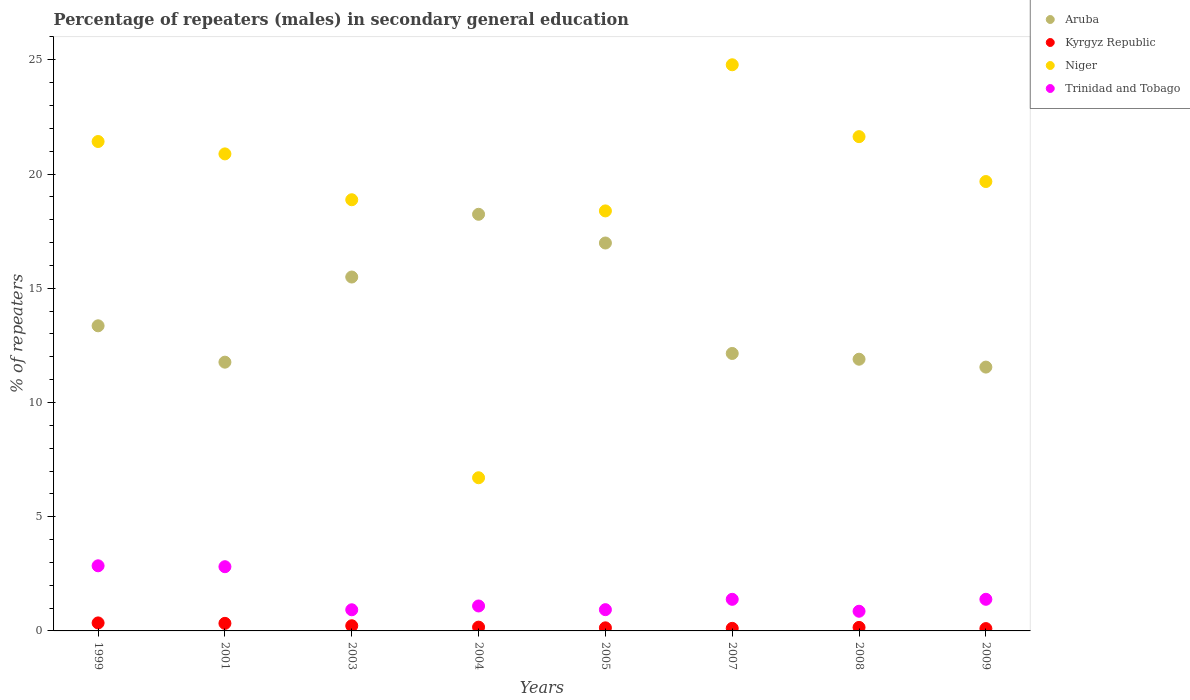Is the number of dotlines equal to the number of legend labels?
Provide a succinct answer. Yes. What is the percentage of male repeaters in Kyrgyz Republic in 1999?
Offer a terse response. 0.35. Across all years, what is the maximum percentage of male repeaters in Niger?
Keep it short and to the point. 24.78. Across all years, what is the minimum percentage of male repeaters in Kyrgyz Republic?
Your answer should be compact. 0.1. In which year was the percentage of male repeaters in Kyrgyz Republic minimum?
Offer a very short reply. 2009. What is the total percentage of male repeaters in Kyrgyz Republic in the graph?
Keep it short and to the point. 1.58. What is the difference between the percentage of male repeaters in Aruba in 2001 and that in 2009?
Offer a terse response. 0.22. What is the difference between the percentage of male repeaters in Trinidad and Tobago in 2005 and the percentage of male repeaters in Niger in 2008?
Keep it short and to the point. -20.71. What is the average percentage of male repeaters in Niger per year?
Make the answer very short. 19.05. In the year 2007, what is the difference between the percentage of male repeaters in Kyrgyz Republic and percentage of male repeaters in Aruba?
Keep it short and to the point. -12.03. In how many years, is the percentage of male repeaters in Aruba greater than 10 %?
Provide a succinct answer. 8. What is the ratio of the percentage of male repeaters in Kyrgyz Republic in 2005 to that in 2007?
Offer a very short reply. 1.2. Is the percentage of male repeaters in Trinidad and Tobago in 2008 less than that in 2009?
Your answer should be very brief. Yes. Is the difference between the percentage of male repeaters in Kyrgyz Republic in 2005 and 2009 greater than the difference between the percentage of male repeaters in Aruba in 2005 and 2009?
Your response must be concise. No. What is the difference between the highest and the second highest percentage of male repeaters in Trinidad and Tobago?
Make the answer very short. 0.04. What is the difference between the highest and the lowest percentage of male repeaters in Niger?
Ensure brevity in your answer.  18.08. In how many years, is the percentage of male repeaters in Niger greater than the average percentage of male repeaters in Niger taken over all years?
Make the answer very short. 5. Does the percentage of male repeaters in Trinidad and Tobago monotonically increase over the years?
Provide a succinct answer. No. Is the percentage of male repeaters in Trinidad and Tobago strictly greater than the percentage of male repeaters in Niger over the years?
Your answer should be very brief. No. Is the percentage of male repeaters in Aruba strictly less than the percentage of male repeaters in Niger over the years?
Give a very brief answer. No. How many dotlines are there?
Make the answer very short. 4. What is the difference between two consecutive major ticks on the Y-axis?
Offer a very short reply. 5. Are the values on the major ticks of Y-axis written in scientific E-notation?
Provide a succinct answer. No. Does the graph contain any zero values?
Ensure brevity in your answer.  No. Does the graph contain grids?
Your answer should be very brief. No. How are the legend labels stacked?
Your response must be concise. Vertical. What is the title of the graph?
Give a very brief answer. Percentage of repeaters (males) in secondary general education. Does "Nepal" appear as one of the legend labels in the graph?
Offer a very short reply. No. What is the label or title of the X-axis?
Offer a very short reply. Years. What is the label or title of the Y-axis?
Make the answer very short. % of repeaters. What is the % of repeaters in Aruba in 1999?
Keep it short and to the point. 13.36. What is the % of repeaters in Kyrgyz Republic in 1999?
Provide a short and direct response. 0.35. What is the % of repeaters in Niger in 1999?
Provide a succinct answer. 21.42. What is the % of repeaters of Trinidad and Tobago in 1999?
Offer a very short reply. 2.85. What is the % of repeaters in Aruba in 2001?
Offer a terse response. 11.76. What is the % of repeaters in Kyrgyz Republic in 2001?
Offer a terse response. 0.33. What is the % of repeaters in Niger in 2001?
Offer a very short reply. 20.88. What is the % of repeaters of Trinidad and Tobago in 2001?
Your response must be concise. 2.81. What is the % of repeaters of Aruba in 2003?
Your answer should be compact. 15.49. What is the % of repeaters of Kyrgyz Republic in 2003?
Your answer should be compact. 0.23. What is the % of repeaters of Niger in 2003?
Make the answer very short. 18.87. What is the % of repeaters of Trinidad and Tobago in 2003?
Offer a terse response. 0.93. What is the % of repeaters in Aruba in 2004?
Your response must be concise. 18.24. What is the % of repeaters of Kyrgyz Republic in 2004?
Your answer should be very brief. 0.17. What is the % of repeaters in Niger in 2004?
Provide a succinct answer. 6.71. What is the % of repeaters in Trinidad and Tobago in 2004?
Give a very brief answer. 1.09. What is the % of repeaters of Aruba in 2005?
Offer a very short reply. 16.98. What is the % of repeaters in Kyrgyz Republic in 2005?
Give a very brief answer. 0.14. What is the % of repeaters in Niger in 2005?
Keep it short and to the point. 18.39. What is the % of repeaters of Trinidad and Tobago in 2005?
Ensure brevity in your answer.  0.93. What is the % of repeaters of Aruba in 2007?
Provide a succinct answer. 12.15. What is the % of repeaters in Kyrgyz Republic in 2007?
Provide a short and direct response. 0.11. What is the % of repeaters in Niger in 2007?
Provide a succinct answer. 24.78. What is the % of repeaters in Trinidad and Tobago in 2007?
Ensure brevity in your answer.  1.38. What is the % of repeaters in Aruba in 2008?
Your answer should be compact. 11.89. What is the % of repeaters in Kyrgyz Republic in 2008?
Make the answer very short. 0.15. What is the % of repeaters in Niger in 2008?
Your response must be concise. 21.64. What is the % of repeaters in Trinidad and Tobago in 2008?
Your answer should be compact. 0.86. What is the % of repeaters in Aruba in 2009?
Your response must be concise. 11.55. What is the % of repeaters of Kyrgyz Republic in 2009?
Provide a short and direct response. 0.1. What is the % of repeaters in Niger in 2009?
Keep it short and to the point. 19.67. What is the % of repeaters in Trinidad and Tobago in 2009?
Your answer should be compact. 1.38. Across all years, what is the maximum % of repeaters of Aruba?
Provide a succinct answer. 18.24. Across all years, what is the maximum % of repeaters in Kyrgyz Republic?
Ensure brevity in your answer.  0.35. Across all years, what is the maximum % of repeaters in Niger?
Give a very brief answer. 24.78. Across all years, what is the maximum % of repeaters of Trinidad and Tobago?
Your answer should be compact. 2.85. Across all years, what is the minimum % of repeaters of Aruba?
Your response must be concise. 11.55. Across all years, what is the minimum % of repeaters of Kyrgyz Republic?
Give a very brief answer. 0.1. Across all years, what is the minimum % of repeaters of Niger?
Your answer should be very brief. 6.71. Across all years, what is the minimum % of repeaters of Trinidad and Tobago?
Make the answer very short. 0.86. What is the total % of repeaters in Aruba in the graph?
Your response must be concise. 111.42. What is the total % of repeaters in Kyrgyz Republic in the graph?
Offer a very short reply. 1.58. What is the total % of repeaters of Niger in the graph?
Give a very brief answer. 152.36. What is the total % of repeaters of Trinidad and Tobago in the graph?
Your response must be concise. 12.24. What is the difference between the % of repeaters in Aruba in 1999 and that in 2001?
Give a very brief answer. 1.59. What is the difference between the % of repeaters in Kyrgyz Republic in 1999 and that in 2001?
Offer a terse response. 0.02. What is the difference between the % of repeaters of Niger in 1999 and that in 2001?
Provide a short and direct response. 0.54. What is the difference between the % of repeaters in Trinidad and Tobago in 1999 and that in 2001?
Offer a terse response. 0.04. What is the difference between the % of repeaters of Aruba in 1999 and that in 2003?
Give a very brief answer. -2.14. What is the difference between the % of repeaters in Kyrgyz Republic in 1999 and that in 2003?
Your response must be concise. 0.12. What is the difference between the % of repeaters in Niger in 1999 and that in 2003?
Offer a terse response. 2.55. What is the difference between the % of repeaters in Trinidad and Tobago in 1999 and that in 2003?
Keep it short and to the point. 1.92. What is the difference between the % of repeaters in Aruba in 1999 and that in 2004?
Ensure brevity in your answer.  -4.88. What is the difference between the % of repeaters in Kyrgyz Republic in 1999 and that in 2004?
Offer a very short reply. 0.18. What is the difference between the % of repeaters of Niger in 1999 and that in 2004?
Give a very brief answer. 14.72. What is the difference between the % of repeaters of Trinidad and Tobago in 1999 and that in 2004?
Make the answer very short. 1.76. What is the difference between the % of repeaters of Aruba in 1999 and that in 2005?
Provide a succinct answer. -3.62. What is the difference between the % of repeaters in Kyrgyz Republic in 1999 and that in 2005?
Offer a terse response. 0.22. What is the difference between the % of repeaters of Niger in 1999 and that in 2005?
Your answer should be very brief. 3.04. What is the difference between the % of repeaters of Trinidad and Tobago in 1999 and that in 2005?
Ensure brevity in your answer.  1.92. What is the difference between the % of repeaters in Aruba in 1999 and that in 2007?
Keep it short and to the point. 1.21. What is the difference between the % of repeaters in Kyrgyz Republic in 1999 and that in 2007?
Your answer should be very brief. 0.24. What is the difference between the % of repeaters in Niger in 1999 and that in 2007?
Ensure brevity in your answer.  -3.36. What is the difference between the % of repeaters in Trinidad and Tobago in 1999 and that in 2007?
Provide a succinct answer. 1.47. What is the difference between the % of repeaters in Aruba in 1999 and that in 2008?
Provide a short and direct response. 1.46. What is the difference between the % of repeaters of Kyrgyz Republic in 1999 and that in 2008?
Make the answer very short. 0.2. What is the difference between the % of repeaters in Niger in 1999 and that in 2008?
Provide a short and direct response. -0.21. What is the difference between the % of repeaters of Trinidad and Tobago in 1999 and that in 2008?
Your answer should be very brief. 1.99. What is the difference between the % of repeaters of Aruba in 1999 and that in 2009?
Ensure brevity in your answer.  1.81. What is the difference between the % of repeaters in Kyrgyz Republic in 1999 and that in 2009?
Make the answer very short. 0.25. What is the difference between the % of repeaters of Niger in 1999 and that in 2009?
Ensure brevity in your answer.  1.75. What is the difference between the % of repeaters of Trinidad and Tobago in 1999 and that in 2009?
Keep it short and to the point. 1.47. What is the difference between the % of repeaters in Aruba in 2001 and that in 2003?
Give a very brief answer. -3.73. What is the difference between the % of repeaters of Kyrgyz Republic in 2001 and that in 2003?
Give a very brief answer. 0.1. What is the difference between the % of repeaters in Niger in 2001 and that in 2003?
Give a very brief answer. 2.01. What is the difference between the % of repeaters in Trinidad and Tobago in 2001 and that in 2003?
Your answer should be compact. 1.89. What is the difference between the % of repeaters in Aruba in 2001 and that in 2004?
Provide a succinct answer. -6.47. What is the difference between the % of repeaters in Kyrgyz Republic in 2001 and that in 2004?
Provide a succinct answer. 0.17. What is the difference between the % of repeaters of Niger in 2001 and that in 2004?
Your answer should be very brief. 14.18. What is the difference between the % of repeaters in Trinidad and Tobago in 2001 and that in 2004?
Make the answer very short. 1.72. What is the difference between the % of repeaters of Aruba in 2001 and that in 2005?
Provide a short and direct response. -5.22. What is the difference between the % of repeaters in Kyrgyz Republic in 2001 and that in 2005?
Provide a succinct answer. 0.2. What is the difference between the % of repeaters of Niger in 2001 and that in 2005?
Provide a short and direct response. 2.5. What is the difference between the % of repeaters in Trinidad and Tobago in 2001 and that in 2005?
Make the answer very short. 1.88. What is the difference between the % of repeaters of Aruba in 2001 and that in 2007?
Offer a very short reply. -0.38. What is the difference between the % of repeaters of Kyrgyz Republic in 2001 and that in 2007?
Provide a short and direct response. 0.22. What is the difference between the % of repeaters in Niger in 2001 and that in 2007?
Offer a terse response. -3.9. What is the difference between the % of repeaters in Trinidad and Tobago in 2001 and that in 2007?
Keep it short and to the point. 1.43. What is the difference between the % of repeaters of Aruba in 2001 and that in 2008?
Provide a succinct answer. -0.13. What is the difference between the % of repeaters of Kyrgyz Republic in 2001 and that in 2008?
Provide a short and direct response. 0.18. What is the difference between the % of repeaters of Niger in 2001 and that in 2008?
Your answer should be compact. -0.75. What is the difference between the % of repeaters of Trinidad and Tobago in 2001 and that in 2008?
Your answer should be very brief. 1.95. What is the difference between the % of repeaters in Aruba in 2001 and that in 2009?
Offer a very short reply. 0.22. What is the difference between the % of repeaters in Kyrgyz Republic in 2001 and that in 2009?
Your answer should be very brief. 0.23. What is the difference between the % of repeaters in Niger in 2001 and that in 2009?
Offer a very short reply. 1.21. What is the difference between the % of repeaters of Trinidad and Tobago in 2001 and that in 2009?
Keep it short and to the point. 1.43. What is the difference between the % of repeaters of Aruba in 2003 and that in 2004?
Offer a terse response. -2.75. What is the difference between the % of repeaters of Kyrgyz Republic in 2003 and that in 2004?
Offer a very short reply. 0.06. What is the difference between the % of repeaters in Niger in 2003 and that in 2004?
Make the answer very short. 12.17. What is the difference between the % of repeaters in Trinidad and Tobago in 2003 and that in 2004?
Provide a succinct answer. -0.17. What is the difference between the % of repeaters in Aruba in 2003 and that in 2005?
Offer a terse response. -1.49. What is the difference between the % of repeaters in Kyrgyz Republic in 2003 and that in 2005?
Your answer should be very brief. 0.09. What is the difference between the % of repeaters in Niger in 2003 and that in 2005?
Your response must be concise. 0.49. What is the difference between the % of repeaters in Trinidad and Tobago in 2003 and that in 2005?
Make the answer very short. -0. What is the difference between the % of repeaters of Aruba in 2003 and that in 2007?
Provide a short and direct response. 3.35. What is the difference between the % of repeaters in Kyrgyz Republic in 2003 and that in 2007?
Make the answer very short. 0.11. What is the difference between the % of repeaters of Niger in 2003 and that in 2007?
Offer a very short reply. -5.91. What is the difference between the % of repeaters of Trinidad and Tobago in 2003 and that in 2007?
Provide a short and direct response. -0.46. What is the difference between the % of repeaters in Aruba in 2003 and that in 2008?
Offer a very short reply. 3.6. What is the difference between the % of repeaters of Kyrgyz Republic in 2003 and that in 2008?
Your answer should be very brief. 0.07. What is the difference between the % of repeaters of Niger in 2003 and that in 2008?
Give a very brief answer. -2.76. What is the difference between the % of repeaters in Trinidad and Tobago in 2003 and that in 2008?
Provide a short and direct response. 0.06. What is the difference between the % of repeaters of Aruba in 2003 and that in 2009?
Provide a short and direct response. 3.94. What is the difference between the % of repeaters in Kyrgyz Republic in 2003 and that in 2009?
Provide a short and direct response. 0.12. What is the difference between the % of repeaters of Niger in 2003 and that in 2009?
Your response must be concise. -0.8. What is the difference between the % of repeaters of Trinidad and Tobago in 2003 and that in 2009?
Your answer should be very brief. -0.46. What is the difference between the % of repeaters of Aruba in 2004 and that in 2005?
Your answer should be very brief. 1.26. What is the difference between the % of repeaters of Kyrgyz Republic in 2004 and that in 2005?
Your answer should be compact. 0.03. What is the difference between the % of repeaters in Niger in 2004 and that in 2005?
Your response must be concise. -11.68. What is the difference between the % of repeaters of Trinidad and Tobago in 2004 and that in 2005?
Give a very brief answer. 0.16. What is the difference between the % of repeaters in Aruba in 2004 and that in 2007?
Give a very brief answer. 6.09. What is the difference between the % of repeaters in Kyrgyz Republic in 2004 and that in 2007?
Provide a succinct answer. 0.05. What is the difference between the % of repeaters of Niger in 2004 and that in 2007?
Keep it short and to the point. -18.08. What is the difference between the % of repeaters of Trinidad and Tobago in 2004 and that in 2007?
Provide a succinct answer. -0.29. What is the difference between the % of repeaters in Aruba in 2004 and that in 2008?
Give a very brief answer. 6.34. What is the difference between the % of repeaters in Kyrgyz Republic in 2004 and that in 2008?
Your response must be concise. 0.01. What is the difference between the % of repeaters in Niger in 2004 and that in 2008?
Offer a very short reply. -14.93. What is the difference between the % of repeaters in Trinidad and Tobago in 2004 and that in 2008?
Your response must be concise. 0.23. What is the difference between the % of repeaters in Aruba in 2004 and that in 2009?
Provide a short and direct response. 6.69. What is the difference between the % of repeaters of Kyrgyz Republic in 2004 and that in 2009?
Your answer should be very brief. 0.06. What is the difference between the % of repeaters of Niger in 2004 and that in 2009?
Your answer should be compact. -12.97. What is the difference between the % of repeaters of Trinidad and Tobago in 2004 and that in 2009?
Ensure brevity in your answer.  -0.29. What is the difference between the % of repeaters of Aruba in 2005 and that in 2007?
Your answer should be very brief. 4.84. What is the difference between the % of repeaters of Kyrgyz Republic in 2005 and that in 2007?
Your answer should be compact. 0.02. What is the difference between the % of repeaters in Niger in 2005 and that in 2007?
Give a very brief answer. -6.4. What is the difference between the % of repeaters of Trinidad and Tobago in 2005 and that in 2007?
Offer a very short reply. -0.45. What is the difference between the % of repeaters of Aruba in 2005 and that in 2008?
Your response must be concise. 5.09. What is the difference between the % of repeaters in Kyrgyz Republic in 2005 and that in 2008?
Ensure brevity in your answer.  -0.02. What is the difference between the % of repeaters of Niger in 2005 and that in 2008?
Your answer should be compact. -3.25. What is the difference between the % of repeaters in Trinidad and Tobago in 2005 and that in 2008?
Give a very brief answer. 0.07. What is the difference between the % of repeaters of Aruba in 2005 and that in 2009?
Give a very brief answer. 5.43. What is the difference between the % of repeaters of Kyrgyz Republic in 2005 and that in 2009?
Provide a succinct answer. 0.03. What is the difference between the % of repeaters in Niger in 2005 and that in 2009?
Give a very brief answer. -1.29. What is the difference between the % of repeaters in Trinidad and Tobago in 2005 and that in 2009?
Offer a very short reply. -0.45. What is the difference between the % of repeaters of Aruba in 2007 and that in 2008?
Give a very brief answer. 0.25. What is the difference between the % of repeaters of Kyrgyz Republic in 2007 and that in 2008?
Your response must be concise. -0.04. What is the difference between the % of repeaters of Niger in 2007 and that in 2008?
Make the answer very short. 3.15. What is the difference between the % of repeaters in Trinidad and Tobago in 2007 and that in 2008?
Give a very brief answer. 0.52. What is the difference between the % of repeaters in Aruba in 2007 and that in 2009?
Keep it short and to the point. 0.6. What is the difference between the % of repeaters of Kyrgyz Republic in 2007 and that in 2009?
Make the answer very short. 0.01. What is the difference between the % of repeaters in Niger in 2007 and that in 2009?
Your answer should be compact. 5.11. What is the difference between the % of repeaters in Trinidad and Tobago in 2007 and that in 2009?
Your answer should be compact. -0. What is the difference between the % of repeaters in Aruba in 2008 and that in 2009?
Make the answer very short. 0.34. What is the difference between the % of repeaters in Kyrgyz Republic in 2008 and that in 2009?
Ensure brevity in your answer.  0.05. What is the difference between the % of repeaters of Niger in 2008 and that in 2009?
Give a very brief answer. 1.96. What is the difference between the % of repeaters of Trinidad and Tobago in 2008 and that in 2009?
Your answer should be compact. -0.52. What is the difference between the % of repeaters in Aruba in 1999 and the % of repeaters in Kyrgyz Republic in 2001?
Provide a short and direct response. 13.03. What is the difference between the % of repeaters of Aruba in 1999 and the % of repeaters of Niger in 2001?
Offer a very short reply. -7.53. What is the difference between the % of repeaters in Aruba in 1999 and the % of repeaters in Trinidad and Tobago in 2001?
Offer a very short reply. 10.55. What is the difference between the % of repeaters of Kyrgyz Republic in 1999 and the % of repeaters of Niger in 2001?
Provide a short and direct response. -20.53. What is the difference between the % of repeaters in Kyrgyz Republic in 1999 and the % of repeaters in Trinidad and Tobago in 2001?
Offer a very short reply. -2.46. What is the difference between the % of repeaters of Niger in 1999 and the % of repeaters of Trinidad and Tobago in 2001?
Provide a short and direct response. 18.61. What is the difference between the % of repeaters of Aruba in 1999 and the % of repeaters of Kyrgyz Republic in 2003?
Give a very brief answer. 13.13. What is the difference between the % of repeaters of Aruba in 1999 and the % of repeaters of Niger in 2003?
Your answer should be compact. -5.52. What is the difference between the % of repeaters of Aruba in 1999 and the % of repeaters of Trinidad and Tobago in 2003?
Your answer should be compact. 12.43. What is the difference between the % of repeaters of Kyrgyz Republic in 1999 and the % of repeaters of Niger in 2003?
Offer a very short reply. -18.52. What is the difference between the % of repeaters of Kyrgyz Republic in 1999 and the % of repeaters of Trinidad and Tobago in 2003?
Offer a very short reply. -0.58. What is the difference between the % of repeaters in Niger in 1999 and the % of repeaters in Trinidad and Tobago in 2003?
Provide a short and direct response. 20.5. What is the difference between the % of repeaters of Aruba in 1999 and the % of repeaters of Kyrgyz Republic in 2004?
Ensure brevity in your answer.  13.19. What is the difference between the % of repeaters of Aruba in 1999 and the % of repeaters of Niger in 2004?
Give a very brief answer. 6.65. What is the difference between the % of repeaters of Aruba in 1999 and the % of repeaters of Trinidad and Tobago in 2004?
Give a very brief answer. 12.26. What is the difference between the % of repeaters of Kyrgyz Republic in 1999 and the % of repeaters of Niger in 2004?
Provide a short and direct response. -6.35. What is the difference between the % of repeaters of Kyrgyz Republic in 1999 and the % of repeaters of Trinidad and Tobago in 2004?
Offer a very short reply. -0.74. What is the difference between the % of repeaters of Niger in 1999 and the % of repeaters of Trinidad and Tobago in 2004?
Your response must be concise. 20.33. What is the difference between the % of repeaters of Aruba in 1999 and the % of repeaters of Kyrgyz Republic in 2005?
Provide a succinct answer. 13.22. What is the difference between the % of repeaters in Aruba in 1999 and the % of repeaters in Niger in 2005?
Keep it short and to the point. -5.03. What is the difference between the % of repeaters in Aruba in 1999 and the % of repeaters in Trinidad and Tobago in 2005?
Give a very brief answer. 12.43. What is the difference between the % of repeaters in Kyrgyz Republic in 1999 and the % of repeaters in Niger in 2005?
Your response must be concise. -18.04. What is the difference between the % of repeaters of Kyrgyz Republic in 1999 and the % of repeaters of Trinidad and Tobago in 2005?
Your answer should be compact. -0.58. What is the difference between the % of repeaters in Niger in 1999 and the % of repeaters in Trinidad and Tobago in 2005?
Keep it short and to the point. 20.49. What is the difference between the % of repeaters in Aruba in 1999 and the % of repeaters in Kyrgyz Republic in 2007?
Provide a succinct answer. 13.24. What is the difference between the % of repeaters in Aruba in 1999 and the % of repeaters in Niger in 2007?
Keep it short and to the point. -11.43. What is the difference between the % of repeaters of Aruba in 1999 and the % of repeaters of Trinidad and Tobago in 2007?
Keep it short and to the point. 11.97. What is the difference between the % of repeaters in Kyrgyz Republic in 1999 and the % of repeaters in Niger in 2007?
Your answer should be compact. -24.43. What is the difference between the % of repeaters in Kyrgyz Republic in 1999 and the % of repeaters in Trinidad and Tobago in 2007?
Provide a succinct answer. -1.03. What is the difference between the % of repeaters in Niger in 1999 and the % of repeaters in Trinidad and Tobago in 2007?
Keep it short and to the point. 20.04. What is the difference between the % of repeaters in Aruba in 1999 and the % of repeaters in Kyrgyz Republic in 2008?
Your answer should be very brief. 13.2. What is the difference between the % of repeaters in Aruba in 1999 and the % of repeaters in Niger in 2008?
Give a very brief answer. -8.28. What is the difference between the % of repeaters in Aruba in 1999 and the % of repeaters in Trinidad and Tobago in 2008?
Give a very brief answer. 12.5. What is the difference between the % of repeaters of Kyrgyz Republic in 1999 and the % of repeaters of Niger in 2008?
Your answer should be very brief. -21.29. What is the difference between the % of repeaters of Kyrgyz Republic in 1999 and the % of repeaters of Trinidad and Tobago in 2008?
Your answer should be very brief. -0.51. What is the difference between the % of repeaters in Niger in 1999 and the % of repeaters in Trinidad and Tobago in 2008?
Provide a short and direct response. 20.56. What is the difference between the % of repeaters of Aruba in 1999 and the % of repeaters of Kyrgyz Republic in 2009?
Ensure brevity in your answer.  13.25. What is the difference between the % of repeaters in Aruba in 1999 and the % of repeaters in Niger in 2009?
Ensure brevity in your answer.  -6.32. What is the difference between the % of repeaters of Aruba in 1999 and the % of repeaters of Trinidad and Tobago in 2009?
Give a very brief answer. 11.97. What is the difference between the % of repeaters in Kyrgyz Republic in 1999 and the % of repeaters in Niger in 2009?
Ensure brevity in your answer.  -19.32. What is the difference between the % of repeaters of Kyrgyz Republic in 1999 and the % of repeaters of Trinidad and Tobago in 2009?
Make the answer very short. -1.03. What is the difference between the % of repeaters of Niger in 1999 and the % of repeaters of Trinidad and Tobago in 2009?
Your response must be concise. 20.04. What is the difference between the % of repeaters in Aruba in 2001 and the % of repeaters in Kyrgyz Republic in 2003?
Offer a terse response. 11.54. What is the difference between the % of repeaters of Aruba in 2001 and the % of repeaters of Niger in 2003?
Keep it short and to the point. -7.11. What is the difference between the % of repeaters in Aruba in 2001 and the % of repeaters in Trinidad and Tobago in 2003?
Your answer should be very brief. 10.84. What is the difference between the % of repeaters in Kyrgyz Republic in 2001 and the % of repeaters in Niger in 2003?
Give a very brief answer. -18.54. What is the difference between the % of repeaters of Kyrgyz Republic in 2001 and the % of repeaters of Trinidad and Tobago in 2003?
Offer a terse response. -0.59. What is the difference between the % of repeaters of Niger in 2001 and the % of repeaters of Trinidad and Tobago in 2003?
Keep it short and to the point. 19.96. What is the difference between the % of repeaters of Aruba in 2001 and the % of repeaters of Kyrgyz Republic in 2004?
Make the answer very short. 11.6. What is the difference between the % of repeaters in Aruba in 2001 and the % of repeaters in Niger in 2004?
Provide a succinct answer. 5.06. What is the difference between the % of repeaters in Aruba in 2001 and the % of repeaters in Trinidad and Tobago in 2004?
Offer a very short reply. 10.67. What is the difference between the % of repeaters of Kyrgyz Republic in 2001 and the % of repeaters of Niger in 2004?
Your answer should be compact. -6.37. What is the difference between the % of repeaters in Kyrgyz Republic in 2001 and the % of repeaters in Trinidad and Tobago in 2004?
Keep it short and to the point. -0.76. What is the difference between the % of repeaters of Niger in 2001 and the % of repeaters of Trinidad and Tobago in 2004?
Ensure brevity in your answer.  19.79. What is the difference between the % of repeaters in Aruba in 2001 and the % of repeaters in Kyrgyz Republic in 2005?
Provide a succinct answer. 11.63. What is the difference between the % of repeaters of Aruba in 2001 and the % of repeaters of Niger in 2005?
Offer a terse response. -6.62. What is the difference between the % of repeaters in Aruba in 2001 and the % of repeaters in Trinidad and Tobago in 2005?
Ensure brevity in your answer.  10.83. What is the difference between the % of repeaters of Kyrgyz Republic in 2001 and the % of repeaters of Niger in 2005?
Ensure brevity in your answer.  -18.05. What is the difference between the % of repeaters in Kyrgyz Republic in 2001 and the % of repeaters in Trinidad and Tobago in 2005?
Keep it short and to the point. -0.6. What is the difference between the % of repeaters in Niger in 2001 and the % of repeaters in Trinidad and Tobago in 2005?
Your answer should be very brief. 19.95. What is the difference between the % of repeaters in Aruba in 2001 and the % of repeaters in Kyrgyz Republic in 2007?
Ensure brevity in your answer.  11.65. What is the difference between the % of repeaters in Aruba in 2001 and the % of repeaters in Niger in 2007?
Your answer should be compact. -13.02. What is the difference between the % of repeaters of Aruba in 2001 and the % of repeaters of Trinidad and Tobago in 2007?
Your answer should be very brief. 10.38. What is the difference between the % of repeaters of Kyrgyz Republic in 2001 and the % of repeaters of Niger in 2007?
Offer a terse response. -24.45. What is the difference between the % of repeaters in Kyrgyz Republic in 2001 and the % of repeaters in Trinidad and Tobago in 2007?
Offer a terse response. -1.05. What is the difference between the % of repeaters in Niger in 2001 and the % of repeaters in Trinidad and Tobago in 2007?
Give a very brief answer. 19.5. What is the difference between the % of repeaters of Aruba in 2001 and the % of repeaters of Kyrgyz Republic in 2008?
Ensure brevity in your answer.  11.61. What is the difference between the % of repeaters of Aruba in 2001 and the % of repeaters of Niger in 2008?
Your answer should be compact. -9.87. What is the difference between the % of repeaters of Aruba in 2001 and the % of repeaters of Trinidad and Tobago in 2008?
Your answer should be very brief. 10.9. What is the difference between the % of repeaters of Kyrgyz Republic in 2001 and the % of repeaters of Niger in 2008?
Give a very brief answer. -21.31. What is the difference between the % of repeaters in Kyrgyz Republic in 2001 and the % of repeaters in Trinidad and Tobago in 2008?
Give a very brief answer. -0.53. What is the difference between the % of repeaters of Niger in 2001 and the % of repeaters of Trinidad and Tobago in 2008?
Provide a succinct answer. 20.02. What is the difference between the % of repeaters of Aruba in 2001 and the % of repeaters of Kyrgyz Republic in 2009?
Your response must be concise. 11.66. What is the difference between the % of repeaters of Aruba in 2001 and the % of repeaters of Niger in 2009?
Ensure brevity in your answer.  -7.91. What is the difference between the % of repeaters of Aruba in 2001 and the % of repeaters of Trinidad and Tobago in 2009?
Ensure brevity in your answer.  10.38. What is the difference between the % of repeaters in Kyrgyz Republic in 2001 and the % of repeaters in Niger in 2009?
Make the answer very short. -19.34. What is the difference between the % of repeaters of Kyrgyz Republic in 2001 and the % of repeaters of Trinidad and Tobago in 2009?
Provide a succinct answer. -1.05. What is the difference between the % of repeaters in Niger in 2001 and the % of repeaters in Trinidad and Tobago in 2009?
Provide a succinct answer. 19.5. What is the difference between the % of repeaters in Aruba in 2003 and the % of repeaters in Kyrgyz Republic in 2004?
Provide a succinct answer. 15.33. What is the difference between the % of repeaters in Aruba in 2003 and the % of repeaters in Niger in 2004?
Offer a terse response. 8.79. What is the difference between the % of repeaters of Aruba in 2003 and the % of repeaters of Trinidad and Tobago in 2004?
Offer a very short reply. 14.4. What is the difference between the % of repeaters in Kyrgyz Republic in 2003 and the % of repeaters in Niger in 2004?
Keep it short and to the point. -6.48. What is the difference between the % of repeaters in Kyrgyz Republic in 2003 and the % of repeaters in Trinidad and Tobago in 2004?
Provide a succinct answer. -0.87. What is the difference between the % of repeaters in Niger in 2003 and the % of repeaters in Trinidad and Tobago in 2004?
Provide a short and direct response. 17.78. What is the difference between the % of repeaters in Aruba in 2003 and the % of repeaters in Kyrgyz Republic in 2005?
Your answer should be very brief. 15.36. What is the difference between the % of repeaters of Aruba in 2003 and the % of repeaters of Niger in 2005?
Keep it short and to the point. -2.89. What is the difference between the % of repeaters in Aruba in 2003 and the % of repeaters in Trinidad and Tobago in 2005?
Give a very brief answer. 14.56. What is the difference between the % of repeaters of Kyrgyz Republic in 2003 and the % of repeaters of Niger in 2005?
Provide a short and direct response. -18.16. What is the difference between the % of repeaters in Kyrgyz Republic in 2003 and the % of repeaters in Trinidad and Tobago in 2005?
Ensure brevity in your answer.  -0.7. What is the difference between the % of repeaters of Niger in 2003 and the % of repeaters of Trinidad and Tobago in 2005?
Your response must be concise. 17.94. What is the difference between the % of repeaters in Aruba in 2003 and the % of repeaters in Kyrgyz Republic in 2007?
Make the answer very short. 15.38. What is the difference between the % of repeaters in Aruba in 2003 and the % of repeaters in Niger in 2007?
Ensure brevity in your answer.  -9.29. What is the difference between the % of repeaters in Aruba in 2003 and the % of repeaters in Trinidad and Tobago in 2007?
Ensure brevity in your answer.  14.11. What is the difference between the % of repeaters of Kyrgyz Republic in 2003 and the % of repeaters of Niger in 2007?
Give a very brief answer. -24.56. What is the difference between the % of repeaters in Kyrgyz Republic in 2003 and the % of repeaters in Trinidad and Tobago in 2007?
Your response must be concise. -1.16. What is the difference between the % of repeaters of Niger in 2003 and the % of repeaters of Trinidad and Tobago in 2007?
Make the answer very short. 17.49. What is the difference between the % of repeaters of Aruba in 2003 and the % of repeaters of Kyrgyz Republic in 2008?
Your answer should be compact. 15.34. What is the difference between the % of repeaters of Aruba in 2003 and the % of repeaters of Niger in 2008?
Keep it short and to the point. -6.15. What is the difference between the % of repeaters of Aruba in 2003 and the % of repeaters of Trinidad and Tobago in 2008?
Your answer should be very brief. 14.63. What is the difference between the % of repeaters of Kyrgyz Republic in 2003 and the % of repeaters of Niger in 2008?
Ensure brevity in your answer.  -21.41. What is the difference between the % of repeaters of Kyrgyz Republic in 2003 and the % of repeaters of Trinidad and Tobago in 2008?
Provide a short and direct response. -0.63. What is the difference between the % of repeaters of Niger in 2003 and the % of repeaters of Trinidad and Tobago in 2008?
Offer a terse response. 18.01. What is the difference between the % of repeaters in Aruba in 2003 and the % of repeaters in Kyrgyz Republic in 2009?
Your response must be concise. 15.39. What is the difference between the % of repeaters in Aruba in 2003 and the % of repeaters in Niger in 2009?
Provide a succinct answer. -4.18. What is the difference between the % of repeaters of Aruba in 2003 and the % of repeaters of Trinidad and Tobago in 2009?
Ensure brevity in your answer.  14.11. What is the difference between the % of repeaters of Kyrgyz Republic in 2003 and the % of repeaters of Niger in 2009?
Your response must be concise. -19.45. What is the difference between the % of repeaters in Kyrgyz Republic in 2003 and the % of repeaters in Trinidad and Tobago in 2009?
Offer a very short reply. -1.16. What is the difference between the % of repeaters of Niger in 2003 and the % of repeaters of Trinidad and Tobago in 2009?
Make the answer very short. 17.49. What is the difference between the % of repeaters of Aruba in 2004 and the % of repeaters of Kyrgyz Republic in 2005?
Make the answer very short. 18.1. What is the difference between the % of repeaters of Aruba in 2004 and the % of repeaters of Niger in 2005?
Give a very brief answer. -0.15. What is the difference between the % of repeaters in Aruba in 2004 and the % of repeaters in Trinidad and Tobago in 2005?
Offer a terse response. 17.31. What is the difference between the % of repeaters in Kyrgyz Republic in 2004 and the % of repeaters in Niger in 2005?
Give a very brief answer. -18.22. What is the difference between the % of repeaters in Kyrgyz Republic in 2004 and the % of repeaters in Trinidad and Tobago in 2005?
Your answer should be very brief. -0.76. What is the difference between the % of repeaters of Niger in 2004 and the % of repeaters of Trinidad and Tobago in 2005?
Provide a short and direct response. 5.77. What is the difference between the % of repeaters in Aruba in 2004 and the % of repeaters in Kyrgyz Republic in 2007?
Ensure brevity in your answer.  18.13. What is the difference between the % of repeaters in Aruba in 2004 and the % of repeaters in Niger in 2007?
Offer a very short reply. -6.55. What is the difference between the % of repeaters in Aruba in 2004 and the % of repeaters in Trinidad and Tobago in 2007?
Offer a terse response. 16.85. What is the difference between the % of repeaters in Kyrgyz Republic in 2004 and the % of repeaters in Niger in 2007?
Provide a succinct answer. -24.62. What is the difference between the % of repeaters in Kyrgyz Republic in 2004 and the % of repeaters in Trinidad and Tobago in 2007?
Ensure brevity in your answer.  -1.22. What is the difference between the % of repeaters in Niger in 2004 and the % of repeaters in Trinidad and Tobago in 2007?
Make the answer very short. 5.32. What is the difference between the % of repeaters of Aruba in 2004 and the % of repeaters of Kyrgyz Republic in 2008?
Offer a terse response. 18.08. What is the difference between the % of repeaters in Aruba in 2004 and the % of repeaters in Niger in 2008?
Give a very brief answer. -3.4. What is the difference between the % of repeaters of Aruba in 2004 and the % of repeaters of Trinidad and Tobago in 2008?
Your answer should be compact. 17.38. What is the difference between the % of repeaters in Kyrgyz Republic in 2004 and the % of repeaters in Niger in 2008?
Provide a succinct answer. -21.47. What is the difference between the % of repeaters in Kyrgyz Republic in 2004 and the % of repeaters in Trinidad and Tobago in 2008?
Give a very brief answer. -0.7. What is the difference between the % of repeaters of Niger in 2004 and the % of repeaters of Trinidad and Tobago in 2008?
Keep it short and to the point. 5.84. What is the difference between the % of repeaters of Aruba in 2004 and the % of repeaters of Kyrgyz Republic in 2009?
Make the answer very short. 18.14. What is the difference between the % of repeaters in Aruba in 2004 and the % of repeaters in Niger in 2009?
Ensure brevity in your answer.  -1.43. What is the difference between the % of repeaters of Aruba in 2004 and the % of repeaters of Trinidad and Tobago in 2009?
Keep it short and to the point. 16.85. What is the difference between the % of repeaters of Kyrgyz Republic in 2004 and the % of repeaters of Niger in 2009?
Make the answer very short. -19.51. What is the difference between the % of repeaters in Kyrgyz Republic in 2004 and the % of repeaters in Trinidad and Tobago in 2009?
Your response must be concise. -1.22. What is the difference between the % of repeaters of Niger in 2004 and the % of repeaters of Trinidad and Tobago in 2009?
Your answer should be very brief. 5.32. What is the difference between the % of repeaters of Aruba in 2005 and the % of repeaters of Kyrgyz Republic in 2007?
Offer a very short reply. 16.87. What is the difference between the % of repeaters of Aruba in 2005 and the % of repeaters of Niger in 2007?
Your response must be concise. -7.8. What is the difference between the % of repeaters of Aruba in 2005 and the % of repeaters of Trinidad and Tobago in 2007?
Ensure brevity in your answer.  15.6. What is the difference between the % of repeaters of Kyrgyz Republic in 2005 and the % of repeaters of Niger in 2007?
Keep it short and to the point. -24.65. What is the difference between the % of repeaters of Kyrgyz Republic in 2005 and the % of repeaters of Trinidad and Tobago in 2007?
Make the answer very short. -1.25. What is the difference between the % of repeaters in Niger in 2005 and the % of repeaters in Trinidad and Tobago in 2007?
Your answer should be very brief. 17. What is the difference between the % of repeaters of Aruba in 2005 and the % of repeaters of Kyrgyz Republic in 2008?
Ensure brevity in your answer.  16.83. What is the difference between the % of repeaters in Aruba in 2005 and the % of repeaters in Niger in 2008?
Your answer should be compact. -4.66. What is the difference between the % of repeaters of Aruba in 2005 and the % of repeaters of Trinidad and Tobago in 2008?
Your answer should be very brief. 16.12. What is the difference between the % of repeaters of Kyrgyz Republic in 2005 and the % of repeaters of Niger in 2008?
Make the answer very short. -21.5. What is the difference between the % of repeaters of Kyrgyz Republic in 2005 and the % of repeaters of Trinidad and Tobago in 2008?
Your answer should be compact. -0.73. What is the difference between the % of repeaters in Niger in 2005 and the % of repeaters in Trinidad and Tobago in 2008?
Provide a short and direct response. 17.52. What is the difference between the % of repeaters in Aruba in 2005 and the % of repeaters in Kyrgyz Republic in 2009?
Make the answer very short. 16.88. What is the difference between the % of repeaters of Aruba in 2005 and the % of repeaters of Niger in 2009?
Your answer should be very brief. -2.69. What is the difference between the % of repeaters in Aruba in 2005 and the % of repeaters in Trinidad and Tobago in 2009?
Give a very brief answer. 15.6. What is the difference between the % of repeaters in Kyrgyz Republic in 2005 and the % of repeaters in Niger in 2009?
Make the answer very short. -19.54. What is the difference between the % of repeaters of Kyrgyz Republic in 2005 and the % of repeaters of Trinidad and Tobago in 2009?
Your answer should be compact. -1.25. What is the difference between the % of repeaters of Niger in 2005 and the % of repeaters of Trinidad and Tobago in 2009?
Provide a succinct answer. 17. What is the difference between the % of repeaters in Aruba in 2007 and the % of repeaters in Kyrgyz Republic in 2008?
Offer a terse response. 11.99. What is the difference between the % of repeaters of Aruba in 2007 and the % of repeaters of Niger in 2008?
Keep it short and to the point. -9.49. What is the difference between the % of repeaters in Aruba in 2007 and the % of repeaters in Trinidad and Tobago in 2008?
Give a very brief answer. 11.28. What is the difference between the % of repeaters of Kyrgyz Republic in 2007 and the % of repeaters of Niger in 2008?
Provide a succinct answer. -21.52. What is the difference between the % of repeaters in Kyrgyz Republic in 2007 and the % of repeaters in Trinidad and Tobago in 2008?
Ensure brevity in your answer.  -0.75. What is the difference between the % of repeaters of Niger in 2007 and the % of repeaters of Trinidad and Tobago in 2008?
Offer a very short reply. 23.92. What is the difference between the % of repeaters in Aruba in 2007 and the % of repeaters in Kyrgyz Republic in 2009?
Your response must be concise. 12.04. What is the difference between the % of repeaters in Aruba in 2007 and the % of repeaters in Niger in 2009?
Keep it short and to the point. -7.53. What is the difference between the % of repeaters in Aruba in 2007 and the % of repeaters in Trinidad and Tobago in 2009?
Ensure brevity in your answer.  10.76. What is the difference between the % of repeaters in Kyrgyz Republic in 2007 and the % of repeaters in Niger in 2009?
Offer a very short reply. -19.56. What is the difference between the % of repeaters in Kyrgyz Republic in 2007 and the % of repeaters in Trinidad and Tobago in 2009?
Provide a short and direct response. -1.27. What is the difference between the % of repeaters in Niger in 2007 and the % of repeaters in Trinidad and Tobago in 2009?
Your answer should be very brief. 23.4. What is the difference between the % of repeaters in Aruba in 2008 and the % of repeaters in Kyrgyz Republic in 2009?
Keep it short and to the point. 11.79. What is the difference between the % of repeaters in Aruba in 2008 and the % of repeaters in Niger in 2009?
Keep it short and to the point. -7.78. What is the difference between the % of repeaters of Aruba in 2008 and the % of repeaters of Trinidad and Tobago in 2009?
Offer a very short reply. 10.51. What is the difference between the % of repeaters in Kyrgyz Republic in 2008 and the % of repeaters in Niger in 2009?
Provide a succinct answer. -19.52. What is the difference between the % of repeaters in Kyrgyz Republic in 2008 and the % of repeaters in Trinidad and Tobago in 2009?
Provide a short and direct response. -1.23. What is the difference between the % of repeaters in Niger in 2008 and the % of repeaters in Trinidad and Tobago in 2009?
Provide a succinct answer. 20.25. What is the average % of repeaters in Aruba per year?
Offer a terse response. 13.93. What is the average % of repeaters in Kyrgyz Republic per year?
Provide a succinct answer. 0.2. What is the average % of repeaters in Niger per year?
Your answer should be compact. 19.05. What is the average % of repeaters of Trinidad and Tobago per year?
Give a very brief answer. 1.53. In the year 1999, what is the difference between the % of repeaters in Aruba and % of repeaters in Kyrgyz Republic?
Your response must be concise. 13.01. In the year 1999, what is the difference between the % of repeaters in Aruba and % of repeaters in Niger?
Provide a succinct answer. -8.07. In the year 1999, what is the difference between the % of repeaters of Aruba and % of repeaters of Trinidad and Tobago?
Your answer should be very brief. 10.51. In the year 1999, what is the difference between the % of repeaters in Kyrgyz Republic and % of repeaters in Niger?
Keep it short and to the point. -21.07. In the year 1999, what is the difference between the % of repeaters of Kyrgyz Republic and % of repeaters of Trinidad and Tobago?
Offer a very short reply. -2.5. In the year 1999, what is the difference between the % of repeaters of Niger and % of repeaters of Trinidad and Tobago?
Your answer should be compact. 18.57. In the year 2001, what is the difference between the % of repeaters of Aruba and % of repeaters of Kyrgyz Republic?
Your answer should be compact. 11.43. In the year 2001, what is the difference between the % of repeaters of Aruba and % of repeaters of Niger?
Your answer should be very brief. -9.12. In the year 2001, what is the difference between the % of repeaters of Aruba and % of repeaters of Trinidad and Tobago?
Provide a short and direct response. 8.95. In the year 2001, what is the difference between the % of repeaters in Kyrgyz Republic and % of repeaters in Niger?
Provide a short and direct response. -20.55. In the year 2001, what is the difference between the % of repeaters in Kyrgyz Republic and % of repeaters in Trinidad and Tobago?
Provide a short and direct response. -2.48. In the year 2001, what is the difference between the % of repeaters of Niger and % of repeaters of Trinidad and Tobago?
Give a very brief answer. 18.07. In the year 2003, what is the difference between the % of repeaters in Aruba and % of repeaters in Kyrgyz Republic?
Give a very brief answer. 15.27. In the year 2003, what is the difference between the % of repeaters of Aruba and % of repeaters of Niger?
Keep it short and to the point. -3.38. In the year 2003, what is the difference between the % of repeaters in Aruba and % of repeaters in Trinidad and Tobago?
Your answer should be very brief. 14.57. In the year 2003, what is the difference between the % of repeaters in Kyrgyz Republic and % of repeaters in Niger?
Your response must be concise. -18.65. In the year 2003, what is the difference between the % of repeaters of Kyrgyz Republic and % of repeaters of Trinidad and Tobago?
Offer a terse response. -0.7. In the year 2003, what is the difference between the % of repeaters of Niger and % of repeaters of Trinidad and Tobago?
Provide a short and direct response. 17.95. In the year 2004, what is the difference between the % of repeaters of Aruba and % of repeaters of Kyrgyz Republic?
Ensure brevity in your answer.  18.07. In the year 2004, what is the difference between the % of repeaters in Aruba and % of repeaters in Niger?
Your answer should be compact. 11.53. In the year 2004, what is the difference between the % of repeaters in Aruba and % of repeaters in Trinidad and Tobago?
Offer a very short reply. 17.15. In the year 2004, what is the difference between the % of repeaters of Kyrgyz Republic and % of repeaters of Niger?
Your answer should be very brief. -6.54. In the year 2004, what is the difference between the % of repeaters in Kyrgyz Republic and % of repeaters in Trinidad and Tobago?
Your response must be concise. -0.93. In the year 2004, what is the difference between the % of repeaters of Niger and % of repeaters of Trinidad and Tobago?
Offer a very short reply. 5.61. In the year 2005, what is the difference between the % of repeaters in Aruba and % of repeaters in Kyrgyz Republic?
Offer a very short reply. 16.85. In the year 2005, what is the difference between the % of repeaters in Aruba and % of repeaters in Niger?
Make the answer very short. -1.4. In the year 2005, what is the difference between the % of repeaters of Aruba and % of repeaters of Trinidad and Tobago?
Provide a short and direct response. 16.05. In the year 2005, what is the difference between the % of repeaters in Kyrgyz Republic and % of repeaters in Niger?
Provide a short and direct response. -18.25. In the year 2005, what is the difference between the % of repeaters of Kyrgyz Republic and % of repeaters of Trinidad and Tobago?
Keep it short and to the point. -0.8. In the year 2005, what is the difference between the % of repeaters of Niger and % of repeaters of Trinidad and Tobago?
Provide a succinct answer. 17.46. In the year 2007, what is the difference between the % of repeaters of Aruba and % of repeaters of Kyrgyz Republic?
Ensure brevity in your answer.  12.03. In the year 2007, what is the difference between the % of repeaters in Aruba and % of repeaters in Niger?
Give a very brief answer. -12.64. In the year 2007, what is the difference between the % of repeaters in Aruba and % of repeaters in Trinidad and Tobago?
Your answer should be very brief. 10.76. In the year 2007, what is the difference between the % of repeaters of Kyrgyz Republic and % of repeaters of Niger?
Keep it short and to the point. -24.67. In the year 2007, what is the difference between the % of repeaters of Kyrgyz Republic and % of repeaters of Trinidad and Tobago?
Your response must be concise. -1.27. In the year 2007, what is the difference between the % of repeaters in Niger and % of repeaters in Trinidad and Tobago?
Your answer should be compact. 23.4. In the year 2008, what is the difference between the % of repeaters in Aruba and % of repeaters in Kyrgyz Republic?
Make the answer very short. 11.74. In the year 2008, what is the difference between the % of repeaters of Aruba and % of repeaters of Niger?
Keep it short and to the point. -9.74. In the year 2008, what is the difference between the % of repeaters in Aruba and % of repeaters in Trinidad and Tobago?
Your response must be concise. 11.03. In the year 2008, what is the difference between the % of repeaters of Kyrgyz Republic and % of repeaters of Niger?
Your answer should be very brief. -21.48. In the year 2008, what is the difference between the % of repeaters of Kyrgyz Republic and % of repeaters of Trinidad and Tobago?
Give a very brief answer. -0.71. In the year 2008, what is the difference between the % of repeaters in Niger and % of repeaters in Trinidad and Tobago?
Your answer should be compact. 20.78. In the year 2009, what is the difference between the % of repeaters of Aruba and % of repeaters of Kyrgyz Republic?
Your response must be concise. 11.45. In the year 2009, what is the difference between the % of repeaters in Aruba and % of repeaters in Niger?
Your response must be concise. -8.12. In the year 2009, what is the difference between the % of repeaters in Aruba and % of repeaters in Trinidad and Tobago?
Keep it short and to the point. 10.16. In the year 2009, what is the difference between the % of repeaters of Kyrgyz Republic and % of repeaters of Niger?
Ensure brevity in your answer.  -19.57. In the year 2009, what is the difference between the % of repeaters in Kyrgyz Republic and % of repeaters in Trinidad and Tobago?
Offer a terse response. -1.28. In the year 2009, what is the difference between the % of repeaters of Niger and % of repeaters of Trinidad and Tobago?
Give a very brief answer. 18.29. What is the ratio of the % of repeaters in Aruba in 1999 to that in 2001?
Your response must be concise. 1.14. What is the ratio of the % of repeaters of Kyrgyz Republic in 1999 to that in 2001?
Your answer should be very brief. 1.06. What is the ratio of the % of repeaters of Niger in 1999 to that in 2001?
Your answer should be compact. 1.03. What is the ratio of the % of repeaters in Trinidad and Tobago in 1999 to that in 2001?
Make the answer very short. 1.01. What is the ratio of the % of repeaters in Aruba in 1999 to that in 2003?
Ensure brevity in your answer.  0.86. What is the ratio of the % of repeaters of Kyrgyz Republic in 1999 to that in 2003?
Offer a very short reply. 1.55. What is the ratio of the % of repeaters of Niger in 1999 to that in 2003?
Your answer should be compact. 1.14. What is the ratio of the % of repeaters in Trinidad and Tobago in 1999 to that in 2003?
Provide a short and direct response. 3.08. What is the ratio of the % of repeaters of Aruba in 1999 to that in 2004?
Offer a very short reply. 0.73. What is the ratio of the % of repeaters in Kyrgyz Republic in 1999 to that in 2004?
Provide a succinct answer. 2.11. What is the ratio of the % of repeaters of Niger in 1999 to that in 2004?
Ensure brevity in your answer.  3.2. What is the ratio of the % of repeaters of Trinidad and Tobago in 1999 to that in 2004?
Keep it short and to the point. 2.61. What is the ratio of the % of repeaters in Aruba in 1999 to that in 2005?
Provide a succinct answer. 0.79. What is the ratio of the % of repeaters of Kyrgyz Republic in 1999 to that in 2005?
Provide a short and direct response. 2.59. What is the ratio of the % of repeaters in Niger in 1999 to that in 2005?
Ensure brevity in your answer.  1.17. What is the ratio of the % of repeaters of Trinidad and Tobago in 1999 to that in 2005?
Your answer should be very brief. 3.06. What is the ratio of the % of repeaters of Aruba in 1999 to that in 2007?
Your response must be concise. 1.1. What is the ratio of the % of repeaters of Kyrgyz Republic in 1999 to that in 2007?
Your answer should be compact. 3.11. What is the ratio of the % of repeaters in Niger in 1999 to that in 2007?
Ensure brevity in your answer.  0.86. What is the ratio of the % of repeaters of Trinidad and Tobago in 1999 to that in 2007?
Your answer should be compact. 2.06. What is the ratio of the % of repeaters of Aruba in 1999 to that in 2008?
Keep it short and to the point. 1.12. What is the ratio of the % of repeaters in Kyrgyz Republic in 1999 to that in 2008?
Provide a short and direct response. 2.28. What is the ratio of the % of repeaters of Niger in 1999 to that in 2008?
Provide a short and direct response. 0.99. What is the ratio of the % of repeaters of Trinidad and Tobago in 1999 to that in 2008?
Provide a succinct answer. 3.31. What is the ratio of the % of repeaters in Aruba in 1999 to that in 2009?
Your response must be concise. 1.16. What is the ratio of the % of repeaters in Kyrgyz Republic in 1999 to that in 2009?
Provide a short and direct response. 3.42. What is the ratio of the % of repeaters in Niger in 1999 to that in 2009?
Give a very brief answer. 1.09. What is the ratio of the % of repeaters in Trinidad and Tobago in 1999 to that in 2009?
Your answer should be compact. 2.06. What is the ratio of the % of repeaters of Aruba in 2001 to that in 2003?
Your answer should be very brief. 0.76. What is the ratio of the % of repeaters of Kyrgyz Republic in 2001 to that in 2003?
Provide a succinct answer. 1.46. What is the ratio of the % of repeaters in Niger in 2001 to that in 2003?
Provide a short and direct response. 1.11. What is the ratio of the % of repeaters of Trinidad and Tobago in 2001 to that in 2003?
Offer a very short reply. 3.04. What is the ratio of the % of repeaters in Aruba in 2001 to that in 2004?
Provide a short and direct response. 0.65. What is the ratio of the % of repeaters in Kyrgyz Republic in 2001 to that in 2004?
Provide a succinct answer. 1.99. What is the ratio of the % of repeaters of Niger in 2001 to that in 2004?
Ensure brevity in your answer.  3.11. What is the ratio of the % of repeaters of Trinidad and Tobago in 2001 to that in 2004?
Give a very brief answer. 2.57. What is the ratio of the % of repeaters of Aruba in 2001 to that in 2005?
Your answer should be very brief. 0.69. What is the ratio of the % of repeaters in Kyrgyz Republic in 2001 to that in 2005?
Provide a succinct answer. 2.45. What is the ratio of the % of repeaters of Niger in 2001 to that in 2005?
Your response must be concise. 1.14. What is the ratio of the % of repeaters of Trinidad and Tobago in 2001 to that in 2005?
Keep it short and to the point. 3.02. What is the ratio of the % of repeaters in Aruba in 2001 to that in 2007?
Make the answer very short. 0.97. What is the ratio of the % of repeaters of Kyrgyz Republic in 2001 to that in 2007?
Provide a succinct answer. 2.94. What is the ratio of the % of repeaters of Niger in 2001 to that in 2007?
Make the answer very short. 0.84. What is the ratio of the % of repeaters of Trinidad and Tobago in 2001 to that in 2007?
Provide a short and direct response. 2.03. What is the ratio of the % of repeaters of Kyrgyz Republic in 2001 to that in 2008?
Your answer should be compact. 2.15. What is the ratio of the % of repeaters in Niger in 2001 to that in 2008?
Provide a succinct answer. 0.97. What is the ratio of the % of repeaters in Trinidad and Tobago in 2001 to that in 2008?
Your response must be concise. 3.26. What is the ratio of the % of repeaters of Aruba in 2001 to that in 2009?
Provide a short and direct response. 1.02. What is the ratio of the % of repeaters in Kyrgyz Republic in 2001 to that in 2009?
Ensure brevity in your answer.  3.24. What is the ratio of the % of repeaters of Niger in 2001 to that in 2009?
Your answer should be very brief. 1.06. What is the ratio of the % of repeaters of Trinidad and Tobago in 2001 to that in 2009?
Offer a very short reply. 2.03. What is the ratio of the % of repeaters in Aruba in 2003 to that in 2004?
Keep it short and to the point. 0.85. What is the ratio of the % of repeaters of Kyrgyz Republic in 2003 to that in 2004?
Make the answer very short. 1.36. What is the ratio of the % of repeaters of Niger in 2003 to that in 2004?
Ensure brevity in your answer.  2.81. What is the ratio of the % of repeaters in Trinidad and Tobago in 2003 to that in 2004?
Make the answer very short. 0.85. What is the ratio of the % of repeaters of Aruba in 2003 to that in 2005?
Offer a very short reply. 0.91. What is the ratio of the % of repeaters in Kyrgyz Republic in 2003 to that in 2005?
Offer a very short reply. 1.67. What is the ratio of the % of repeaters in Niger in 2003 to that in 2005?
Provide a short and direct response. 1.03. What is the ratio of the % of repeaters in Aruba in 2003 to that in 2007?
Offer a very short reply. 1.28. What is the ratio of the % of repeaters of Kyrgyz Republic in 2003 to that in 2007?
Make the answer very short. 2.01. What is the ratio of the % of repeaters in Niger in 2003 to that in 2007?
Offer a very short reply. 0.76. What is the ratio of the % of repeaters in Trinidad and Tobago in 2003 to that in 2007?
Give a very brief answer. 0.67. What is the ratio of the % of repeaters in Aruba in 2003 to that in 2008?
Provide a succinct answer. 1.3. What is the ratio of the % of repeaters in Kyrgyz Republic in 2003 to that in 2008?
Ensure brevity in your answer.  1.47. What is the ratio of the % of repeaters of Niger in 2003 to that in 2008?
Your answer should be compact. 0.87. What is the ratio of the % of repeaters of Trinidad and Tobago in 2003 to that in 2008?
Provide a succinct answer. 1.07. What is the ratio of the % of repeaters of Aruba in 2003 to that in 2009?
Provide a short and direct response. 1.34. What is the ratio of the % of repeaters of Kyrgyz Republic in 2003 to that in 2009?
Keep it short and to the point. 2.21. What is the ratio of the % of repeaters of Niger in 2003 to that in 2009?
Keep it short and to the point. 0.96. What is the ratio of the % of repeaters in Trinidad and Tobago in 2003 to that in 2009?
Provide a short and direct response. 0.67. What is the ratio of the % of repeaters in Aruba in 2004 to that in 2005?
Offer a very short reply. 1.07. What is the ratio of the % of repeaters in Kyrgyz Republic in 2004 to that in 2005?
Offer a very short reply. 1.23. What is the ratio of the % of repeaters of Niger in 2004 to that in 2005?
Make the answer very short. 0.36. What is the ratio of the % of repeaters in Trinidad and Tobago in 2004 to that in 2005?
Make the answer very short. 1.17. What is the ratio of the % of repeaters in Aruba in 2004 to that in 2007?
Provide a short and direct response. 1.5. What is the ratio of the % of repeaters in Kyrgyz Republic in 2004 to that in 2007?
Provide a short and direct response. 1.47. What is the ratio of the % of repeaters in Niger in 2004 to that in 2007?
Keep it short and to the point. 0.27. What is the ratio of the % of repeaters in Trinidad and Tobago in 2004 to that in 2007?
Provide a short and direct response. 0.79. What is the ratio of the % of repeaters in Aruba in 2004 to that in 2008?
Give a very brief answer. 1.53. What is the ratio of the % of repeaters of Kyrgyz Republic in 2004 to that in 2008?
Your answer should be very brief. 1.08. What is the ratio of the % of repeaters in Niger in 2004 to that in 2008?
Give a very brief answer. 0.31. What is the ratio of the % of repeaters of Trinidad and Tobago in 2004 to that in 2008?
Your response must be concise. 1.27. What is the ratio of the % of repeaters of Aruba in 2004 to that in 2009?
Offer a very short reply. 1.58. What is the ratio of the % of repeaters in Kyrgyz Republic in 2004 to that in 2009?
Make the answer very short. 1.62. What is the ratio of the % of repeaters in Niger in 2004 to that in 2009?
Provide a succinct answer. 0.34. What is the ratio of the % of repeaters of Trinidad and Tobago in 2004 to that in 2009?
Your response must be concise. 0.79. What is the ratio of the % of repeaters of Aruba in 2005 to that in 2007?
Provide a succinct answer. 1.4. What is the ratio of the % of repeaters in Kyrgyz Republic in 2005 to that in 2007?
Offer a terse response. 1.2. What is the ratio of the % of repeaters of Niger in 2005 to that in 2007?
Ensure brevity in your answer.  0.74. What is the ratio of the % of repeaters in Trinidad and Tobago in 2005 to that in 2007?
Offer a terse response. 0.67. What is the ratio of the % of repeaters of Aruba in 2005 to that in 2008?
Make the answer very short. 1.43. What is the ratio of the % of repeaters in Kyrgyz Republic in 2005 to that in 2008?
Your answer should be very brief. 0.88. What is the ratio of the % of repeaters of Niger in 2005 to that in 2008?
Ensure brevity in your answer.  0.85. What is the ratio of the % of repeaters in Trinidad and Tobago in 2005 to that in 2008?
Give a very brief answer. 1.08. What is the ratio of the % of repeaters of Aruba in 2005 to that in 2009?
Your response must be concise. 1.47. What is the ratio of the % of repeaters in Kyrgyz Republic in 2005 to that in 2009?
Offer a terse response. 1.32. What is the ratio of the % of repeaters in Niger in 2005 to that in 2009?
Provide a succinct answer. 0.93. What is the ratio of the % of repeaters of Trinidad and Tobago in 2005 to that in 2009?
Ensure brevity in your answer.  0.67. What is the ratio of the % of repeaters in Aruba in 2007 to that in 2008?
Offer a very short reply. 1.02. What is the ratio of the % of repeaters of Kyrgyz Republic in 2007 to that in 2008?
Give a very brief answer. 0.73. What is the ratio of the % of repeaters of Niger in 2007 to that in 2008?
Keep it short and to the point. 1.15. What is the ratio of the % of repeaters of Trinidad and Tobago in 2007 to that in 2008?
Offer a terse response. 1.61. What is the ratio of the % of repeaters in Aruba in 2007 to that in 2009?
Provide a succinct answer. 1.05. What is the ratio of the % of repeaters of Kyrgyz Republic in 2007 to that in 2009?
Make the answer very short. 1.1. What is the ratio of the % of repeaters of Niger in 2007 to that in 2009?
Give a very brief answer. 1.26. What is the ratio of the % of repeaters in Aruba in 2008 to that in 2009?
Your answer should be compact. 1.03. What is the ratio of the % of repeaters of Kyrgyz Republic in 2008 to that in 2009?
Offer a terse response. 1.5. What is the ratio of the % of repeaters of Niger in 2008 to that in 2009?
Make the answer very short. 1.1. What is the ratio of the % of repeaters of Trinidad and Tobago in 2008 to that in 2009?
Give a very brief answer. 0.62. What is the difference between the highest and the second highest % of repeaters of Aruba?
Offer a terse response. 1.26. What is the difference between the highest and the second highest % of repeaters in Kyrgyz Republic?
Your response must be concise. 0.02. What is the difference between the highest and the second highest % of repeaters of Niger?
Your answer should be very brief. 3.15. What is the difference between the highest and the second highest % of repeaters in Trinidad and Tobago?
Offer a very short reply. 0.04. What is the difference between the highest and the lowest % of repeaters of Aruba?
Your response must be concise. 6.69. What is the difference between the highest and the lowest % of repeaters in Kyrgyz Republic?
Provide a succinct answer. 0.25. What is the difference between the highest and the lowest % of repeaters in Niger?
Your answer should be very brief. 18.08. What is the difference between the highest and the lowest % of repeaters in Trinidad and Tobago?
Ensure brevity in your answer.  1.99. 